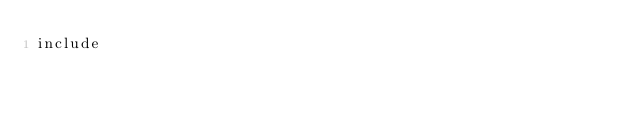<code> <loc_0><loc_0><loc_500><loc_500><_C_>include</code> 